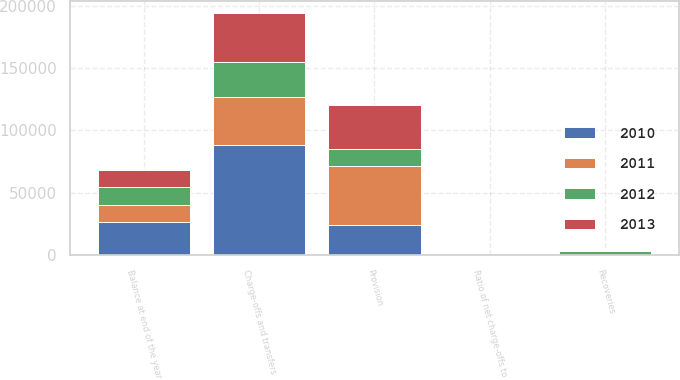<chart> <loc_0><loc_0><loc_500><loc_500><stacked_bar_chart><ecel><fcel>Provision<fcel>Recoveries<fcel>Charge-offs and transfers<fcel>Balance at end of the year<fcel>Ratio of net charge-offs to<nl><fcel>2012<fcel>13250<fcel>3253<fcel>28633<fcel>14314<fcel>6.37<nl><fcel>2010<fcel>23875<fcel>252<fcel>88170<fcel>26444<fcel>19.61<nl><fcel>2013<fcel>35200<fcel>272<fcel>38520<fcel>13782<fcel>5.96<nl><fcel>2011<fcel>47750<fcel>88<fcel>38376<fcel>13782<fcel>4.95<nl></chart> 